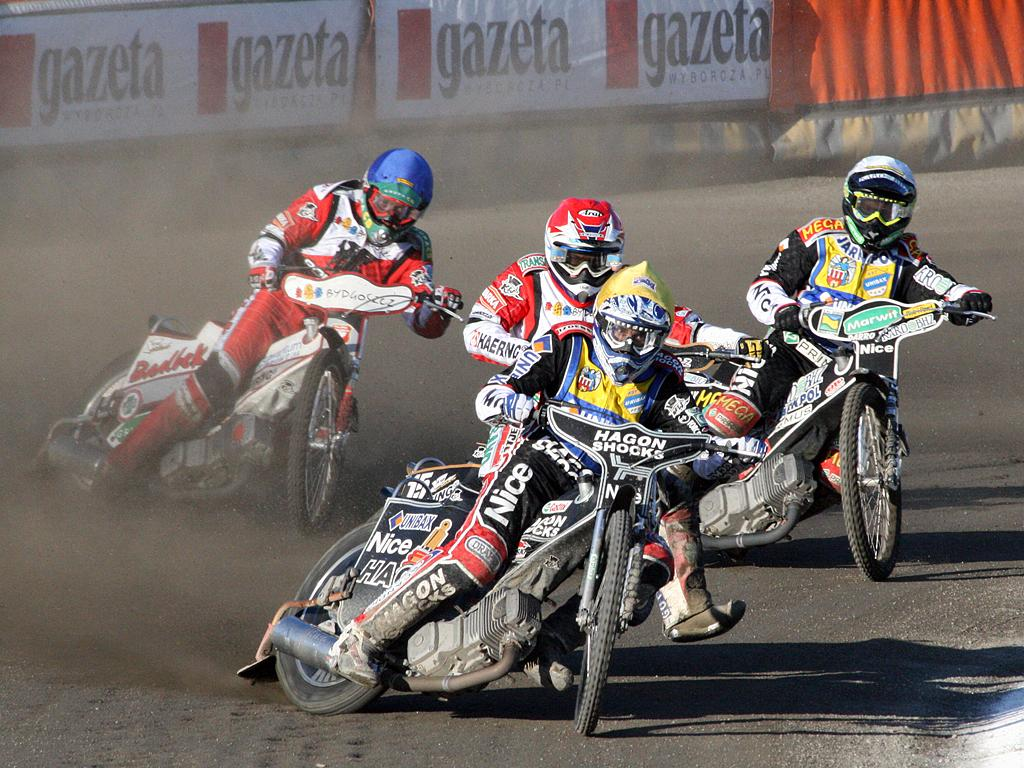What are the people in the image doing? The people in the image are riding motorcycles. Where are the motorcycles located in the image? The motorcycles are in the middle of the image. What can be seen behind the motorcycles in the image? There is fencing visible behind the motorcycles. What type of beast is being cooked on the grill in the image? There is no grill or beast present in the image; it features people riding motorcycles with fencing in the background. 